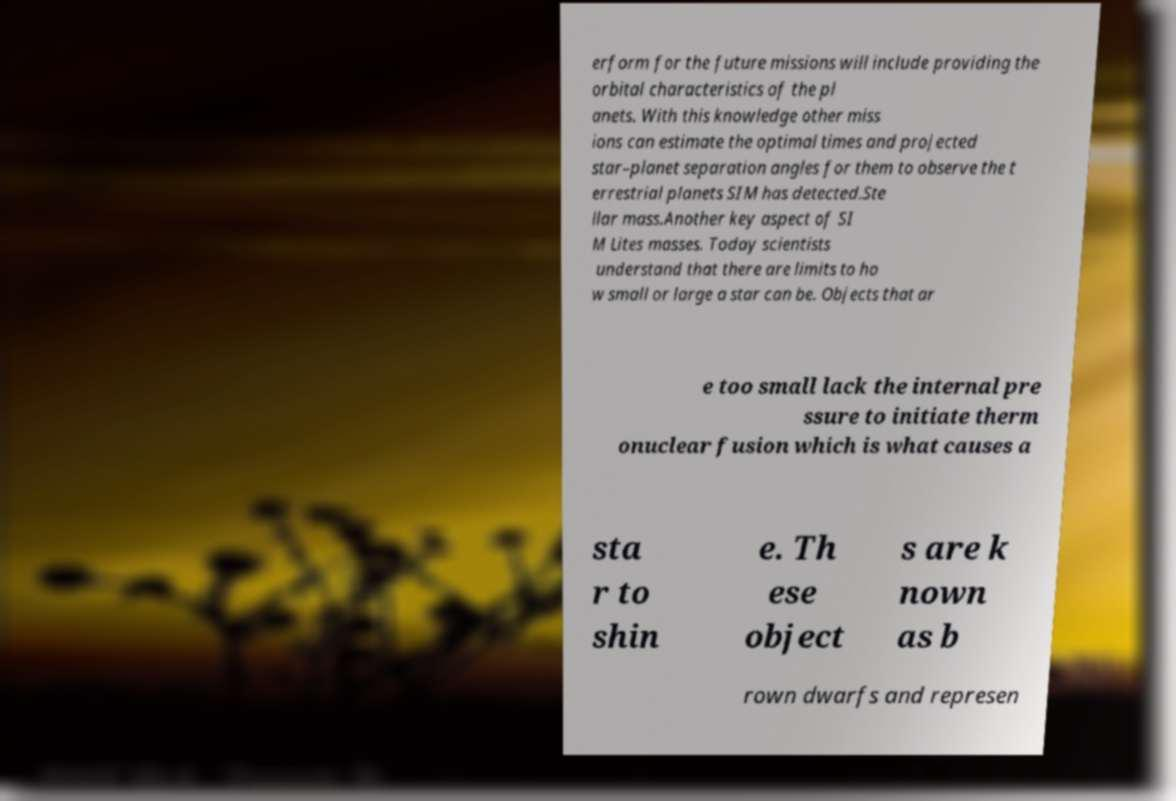Could you assist in decoding the text presented in this image and type it out clearly? erform for the future missions will include providing the orbital characteristics of the pl anets. With this knowledge other miss ions can estimate the optimal times and projected star–planet separation angles for them to observe the t errestrial planets SIM has detected.Ste llar mass.Another key aspect of SI M Lites masses. Today scientists understand that there are limits to ho w small or large a star can be. Objects that ar e too small lack the internal pre ssure to initiate therm onuclear fusion which is what causes a sta r to shin e. Th ese object s are k nown as b rown dwarfs and represen 